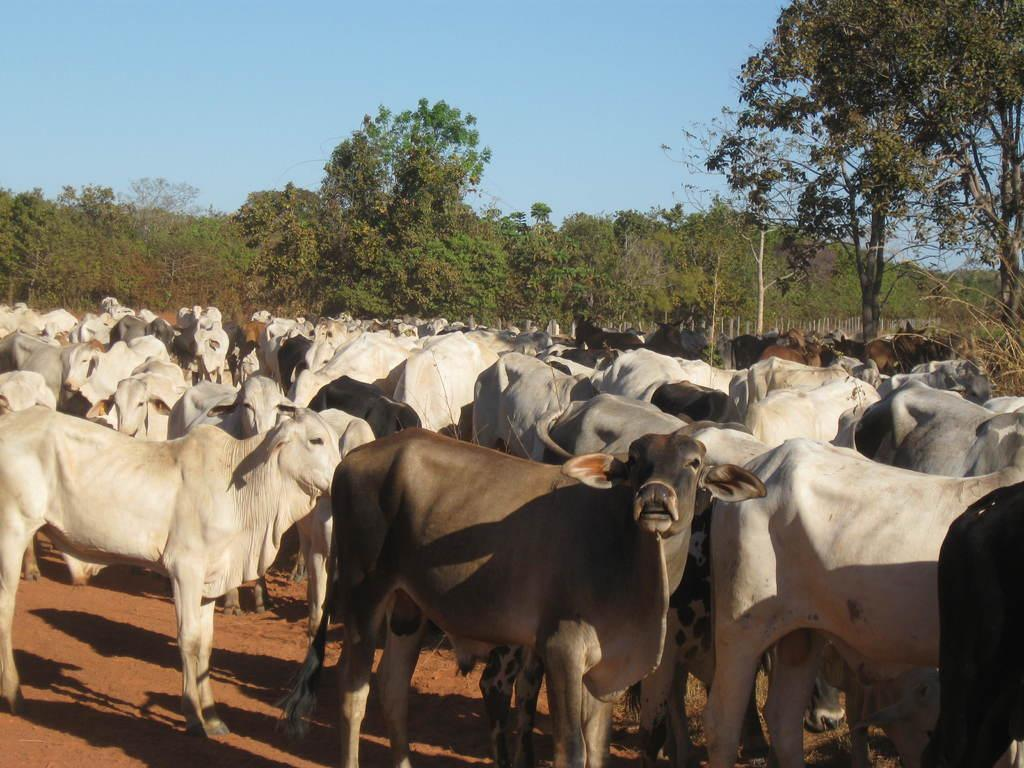What type of animals can be seen on the ground in the image? There are many cows on the ground in the image. What can be seen in the background of the image? There are many trees in the background of the image. What is visible at the top of the image? The sky is visible at the top of the image. How many rabbits can be seen hopping on their feet in the image? There are no rabbits present in the image, and therefore no such activity can be observed. 